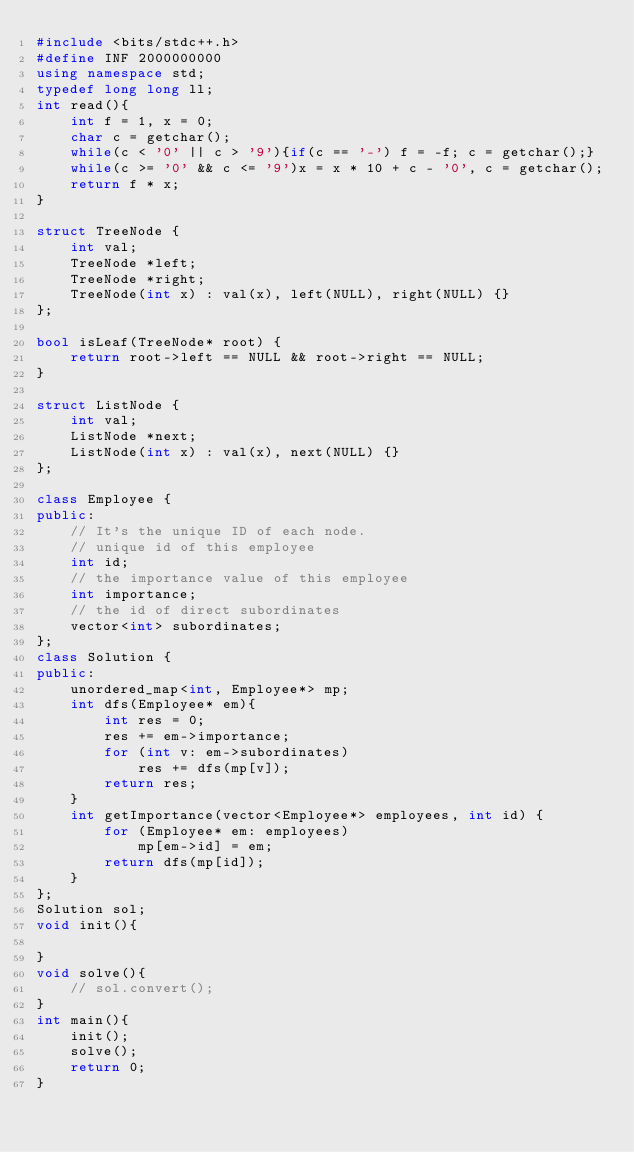Convert code to text. <code><loc_0><loc_0><loc_500><loc_500><_C++_>#include <bits/stdc++.h>
#define INF 2000000000
using namespace std;
typedef long long ll;
int read(){
    int f = 1, x = 0;
    char c = getchar();
    while(c < '0' || c > '9'){if(c == '-') f = -f; c = getchar();}
    while(c >= '0' && c <= '9')x = x * 10 + c - '0', c = getchar();
    return f * x; 
}

struct TreeNode {
    int val;
    TreeNode *left;
    TreeNode *right;
    TreeNode(int x) : val(x), left(NULL), right(NULL) {}
};

bool isLeaf(TreeNode* root) {
    return root->left == NULL && root->right == NULL;
}

struct ListNode {
    int val;
    ListNode *next;
    ListNode(int x) : val(x), next(NULL) {}
};

class Employee {
public:
    // It's the unique ID of each node.
    // unique id of this employee
    int id;
    // the importance value of this employee
    int importance;
    // the id of direct subordinates
    vector<int> subordinates;
};
class Solution {
public:
    unordered_map<int, Employee*> mp;
    int dfs(Employee* em){
        int res = 0;
        res += em->importance;
        for (int v: em->subordinates)
            res += dfs(mp[v]);
        return res;
    }
    int getImportance(vector<Employee*> employees, int id) {
        for (Employee* em: employees)
            mp[em->id] = em;
        return dfs(mp[id]);
    }
};
Solution sol;
void init(){
    
}
void solve(){
    // sol.convert();
}
int main(){
    init();
    solve();
    return 0;
}
</code> 